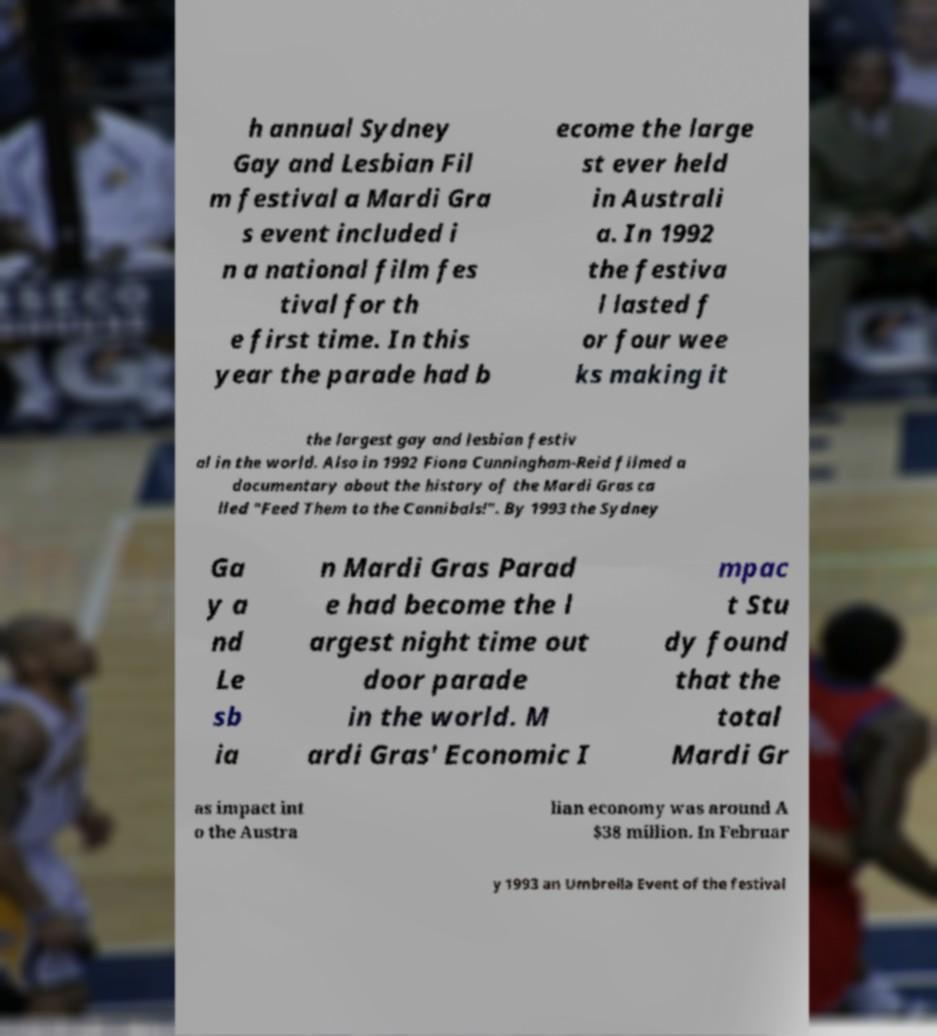I need the written content from this picture converted into text. Can you do that? h annual Sydney Gay and Lesbian Fil m festival a Mardi Gra s event included i n a national film fes tival for th e first time. In this year the parade had b ecome the large st ever held in Australi a. In 1992 the festiva l lasted f or four wee ks making it the largest gay and lesbian festiv al in the world. Also in 1992 Fiona Cunningham-Reid filmed a documentary about the history of the Mardi Gras ca lled "Feed Them to the Cannibals!". By 1993 the Sydney Ga y a nd Le sb ia n Mardi Gras Parad e had become the l argest night time out door parade in the world. M ardi Gras' Economic I mpac t Stu dy found that the total Mardi Gr as impact int o the Austra lian economy was around A $38 million. In Februar y 1993 an Umbrella Event of the festival 